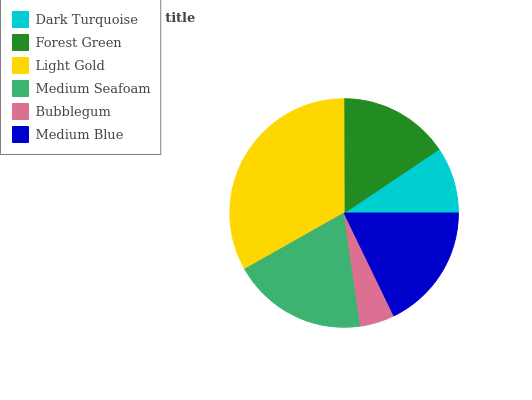Is Bubblegum the minimum?
Answer yes or no. Yes. Is Light Gold the maximum?
Answer yes or no. Yes. Is Forest Green the minimum?
Answer yes or no. No. Is Forest Green the maximum?
Answer yes or no. No. Is Forest Green greater than Dark Turquoise?
Answer yes or no. Yes. Is Dark Turquoise less than Forest Green?
Answer yes or no. Yes. Is Dark Turquoise greater than Forest Green?
Answer yes or no. No. Is Forest Green less than Dark Turquoise?
Answer yes or no. No. Is Medium Blue the high median?
Answer yes or no. Yes. Is Forest Green the low median?
Answer yes or no. Yes. Is Bubblegum the high median?
Answer yes or no. No. Is Medium Blue the low median?
Answer yes or no. No. 